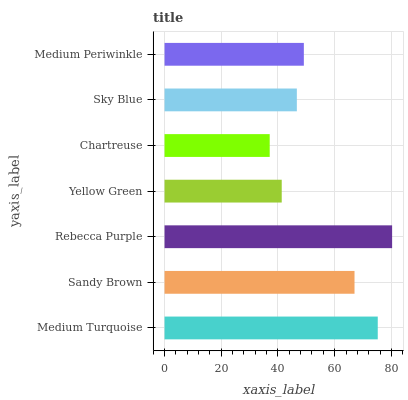Is Chartreuse the minimum?
Answer yes or no. Yes. Is Rebecca Purple the maximum?
Answer yes or no. Yes. Is Sandy Brown the minimum?
Answer yes or no. No. Is Sandy Brown the maximum?
Answer yes or no. No. Is Medium Turquoise greater than Sandy Brown?
Answer yes or no. Yes. Is Sandy Brown less than Medium Turquoise?
Answer yes or no. Yes. Is Sandy Brown greater than Medium Turquoise?
Answer yes or no. No. Is Medium Turquoise less than Sandy Brown?
Answer yes or no. No. Is Medium Periwinkle the high median?
Answer yes or no. Yes. Is Medium Periwinkle the low median?
Answer yes or no. Yes. Is Medium Turquoise the high median?
Answer yes or no. No. Is Chartreuse the low median?
Answer yes or no. No. 